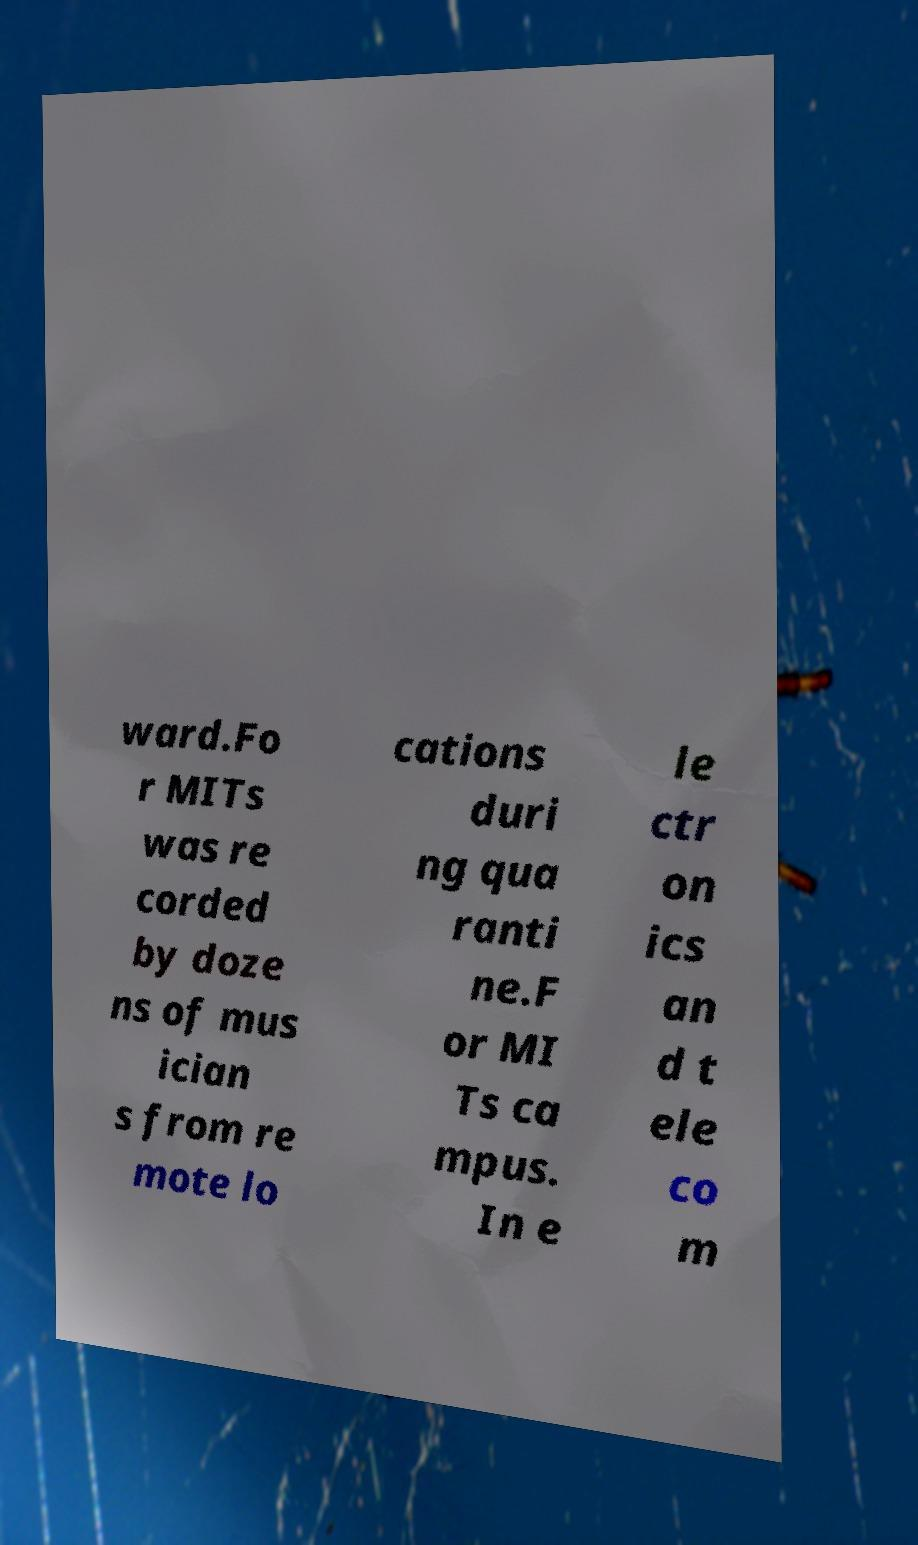There's text embedded in this image that I need extracted. Can you transcribe it verbatim? ward.Fo r MITs was re corded by doze ns of mus ician s from re mote lo cations duri ng qua ranti ne.F or MI Ts ca mpus. In e le ctr on ics an d t ele co m 